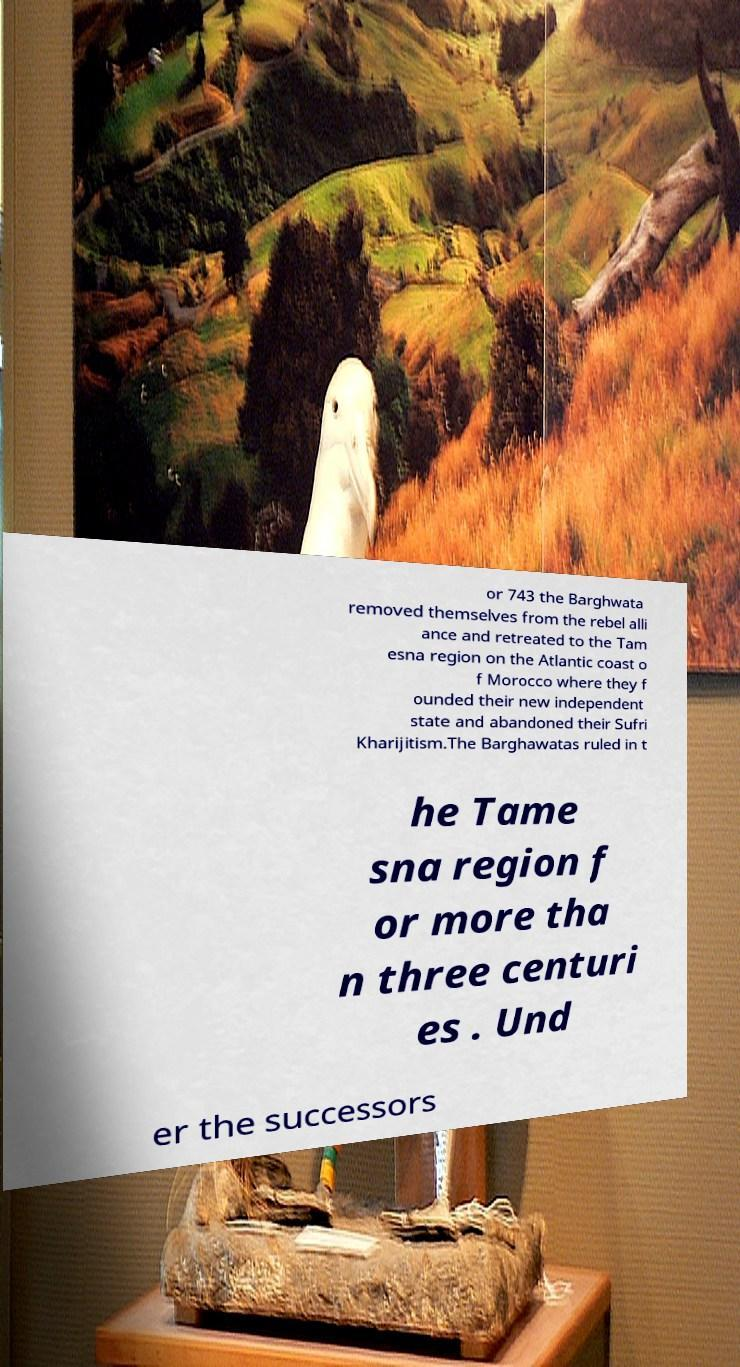Can you accurately transcribe the text from the provided image for me? or 743 the Barghwata removed themselves from the rebel alli ance and retreated to the Tam esna region on the Atlantic coast o f Morocco where they f ounded their new independent state and abandoned their Sufri Kharijitism.The Barghawatas ruled in t he Tame sna region f or more tha n three centuri es . Und er the successors 